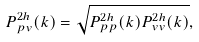<formula> <loc_0><loc_0><loc_500><loc_500>P ^ { 2 h } _ { p v } ( k ) = \sqrt { P ^ { 2 h } _ { p p } ( k ) P ^ { 2 h } _ { v v } ( k ) } ,</formula> 